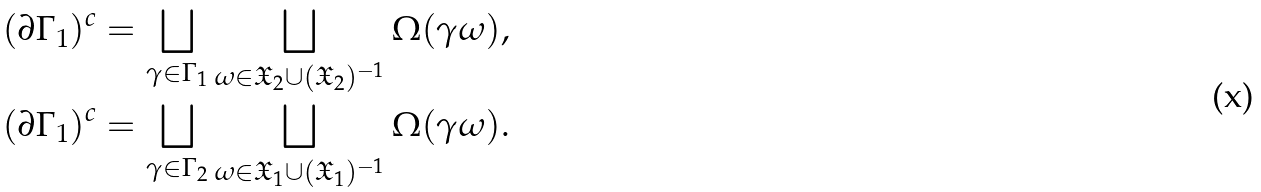Convert formula to latex. <formula><loc_0><loc_0><loc_500><loc_500>( \partial \Gamma _ { 1 } ) ^ { c } = \bigsqcup _ { \gamma \in \Gamma _ { 1 } } \bigsqcup _ { \omega \in { \mathfrak X } _ { 2 } \cup ( { \mathfrak X } _ { 2 } ) ^ { - 1 } } \Omega ( \gamma \omega ) , \\ ( \partial \Gamma _ { 1 } ) ^ { c } = \bigsqcup _ { \gamma \in \Gamma _ { 2 } } \bigsqcup _ { \omega \in { \mathfrak X } _ { 1 } \cup ( { \mathfrak X } _ { 1 } ) ^ { - 1 } } \Omega ( \gamma \omega ) .</formula> 